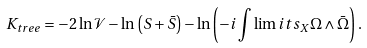Convert formula to latex. <formula><loc_0><loc_0><loc_500><loc_500>K _ { t r e e } = - 2 \ln \mathcal { V } - \ln \left ( S + \bar { S } \right ) - \ln \left ( - i \int \lim i t s _ { X } \Omega \wedge \bar { \Omega } \right ) .</formula> 